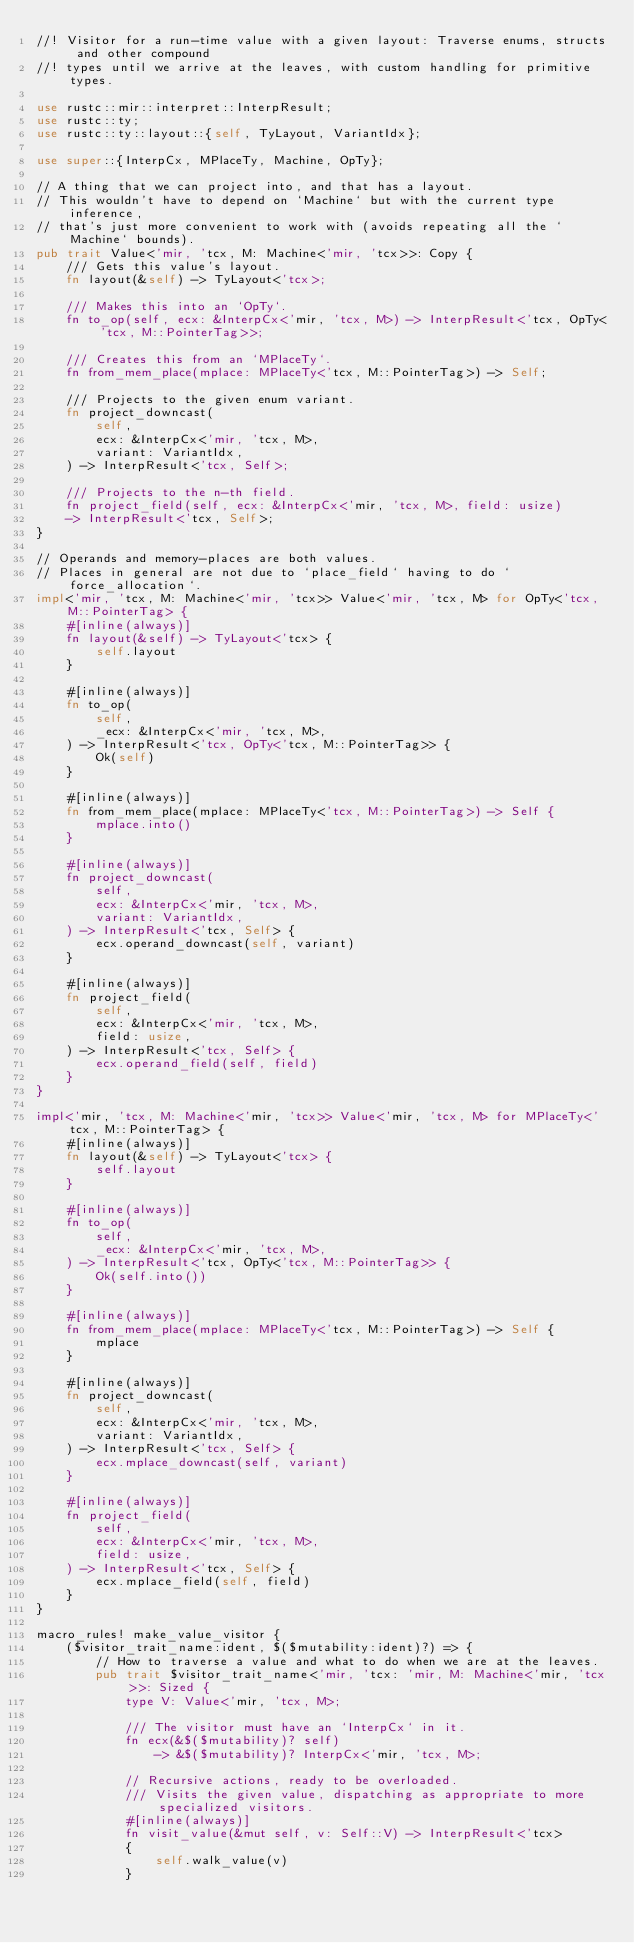<code> <loc_0><loc_0><loc_500><loc_500><_Rust_>//! Visitor for a run-time value with a given layout: Traverse enums, structs and other compound
//! types until we arrive at the leaves, with custom handling for primitive types.

use rustc::mir::interpret::InterpResult;
use rustc::ty;
use rustc::ty::layout::{self, TyLayout, VariantIdx};

use super::{InterpCx, MPlaceTy, Machine, OpTy};

// A thing that we can project into, and that has a layout.
// This wouldn't have to depend on `Machine` but with the current type inference,
// that's just more convenient to work with (avoids repeating all the `Machine` bounds).
pub trait Value<'mir, 'tcx, M: Machine<'mir, 'tcx>>: Copy {
    /// Gets this value's layout.
    fn layout(&self) -> TyLayout<'tcx>;

    /// Makes this into an `OpTy`.
    fn to_op(self, ecx: &InterpCx<'mir, 'tcx, M>) -> InterpResult<'tcx, OpTy<'tcx, M::PointerTag>>;

    /// Creates this from an `MPlaceTy`.
    fn from_mem_place(mplace: MPlaceTy<'tcx, M::PointerTag>) -> Self;

    /// Projects to the given enum variant.
    fn project_downcast(
        self,
        ecx: &InterpCx<'mir, 'tcx, M>,
        variant: VariantIdx,
    ) -> InterpResult<'tcx, Self>;

    /// Projects to the n-th field.
    fn project_field(self, ecx: &InterpCx<'mir, 'tcx, M>, field: usize)
    -> InterpResult<'tcx, Self>;
}

// Operands and memory-places are both values.
// Places in general are not due to `place_field` having to do `force_allocation`.
impl<'mir, 'tcx, M: Machine<'mir, 'tcx>> Value<'mir, 'tcx, M> for OpTy<'tcx, M::PointerTag> {
    #[inline(always)]
    fn layout(&self) -> TyLayout<'tcx> {
        self.layout
    }

    #[inline(always)]
    fn to_op(
        self,
        _ecx: &InterpCx<'mir, 'tcx, M>,
    ) -> InterpResult<'tcx, OpTy<'tcx, M::PointerTag>> {
        Ok(self)
    }

    #[inline(always)]
    fn from_mem_place(mplace: MPlaceTy<'tcx, M::PointerTag>) -> Self {
        mplace.into()
    }

    #[inline(always)]
    fn project_downcast(
        self,
        ecx: &InterpCx<'mir, 'tcx, M>,
        variant: VariantIdx,
    ) -> InterpResult<'tcx, Self> {
        ecx.operand_downcast(self, variant)
    }

    #[inline(always)]
    fn project_field(
        self,
        ecx: &InterpCx<'mir, 'tcx, M>,
        field: usize,
    ) -> InterpResult<'tcx, Self> {
        ecx.operand_field(self, field)
    }
}

impl<'mir, 'tcx, M: Machine<'mir, 'tcx>> Value<'mir, 'tcx, M> for MPlaceTy<'tcx, M::PointerTag> {
    #[inline(always)]
    fn layout(&self) -> TyLayout<'tcx> {
        self.layout
    }

    #[inline(always)]
    fn to_op(
        self,
        _ecx: &InterpCx<'mir, 'tcx, M>,
    ) -> InterpResult<'tcx, OpTy<'tcx, M::PointerTag>> {
        Ok(self.into())
    }

    #[inline(always)]
    fn from_mem_place(mplace: MPlaceTy<'tcx, M::PointerTag>) -> Self {
        mplace
    }

    #[inline(always)]
    fn project_downcast(
        self,
        ecx: &InterpCx<'mir, 'tcx, M>,
        variant: VariantIdx,
    ) -> InterpResult<'tcx, Self> {
        ecx.mplace_downcast(self, variant)
    }

    #[inline(always)]
    fn project_field(
        self,
        ecx: &InterpCx<'mir, 'tcx, M>,
        field: usize,
    ) -> InterpResult<'tcx, Self> {
        ecx.mplace_field(self, field)
    }
}

macro_rules! make_value_visitor {
    ($visitor_trait_name:ident, $($mutability:ident)?) => {
        // How to traverse a value and what to do when we are at the leaves.
        pub trait $visitor_trait_name<'mir, 'tcx: 'mir, M: Machine<'mir, 'tcx>>: Sized {
            type V: Value<'mir, 'tcx, M>;

            /// The visitor must have an `InterpCx` in it.
            fn ecx(&$($mutability)? self)
                -> &$($mutability)? InterpCx<'mir, 'tcx, M>;

            // Recursive actions, ready to be overloaded.
            /// Visits the given value, dispatching as appropriate to more specialized visitors.
            #[inline(always)]
            fn visit_value(&mut self, v: Self::V) -> InterpResult<'tcx>
            {
                self.walk_value(v)
            }</code> 